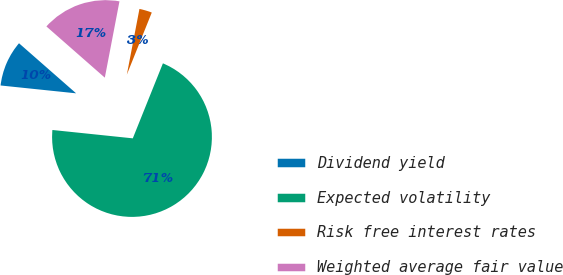Convert chart to OTSL. <chart><loc_0><loc_0><loc_500><loc_500><pie_chart><fcel>Dividend yield<fcel>Expected volatility<fcel>Risk free interest rates<fcel>Weighted average fair value<nl><fcel>9.81%<fcel>70.57%<fcel>3.06%<fcel>16.56%<nl></chart> 